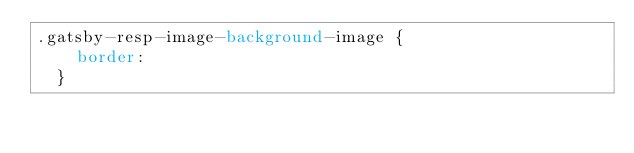<code> <loc_0><loc_0><loc_500><loc_500><_CSS_>.gatsby-resp-image-background-image {
    border: 
  }</code> 